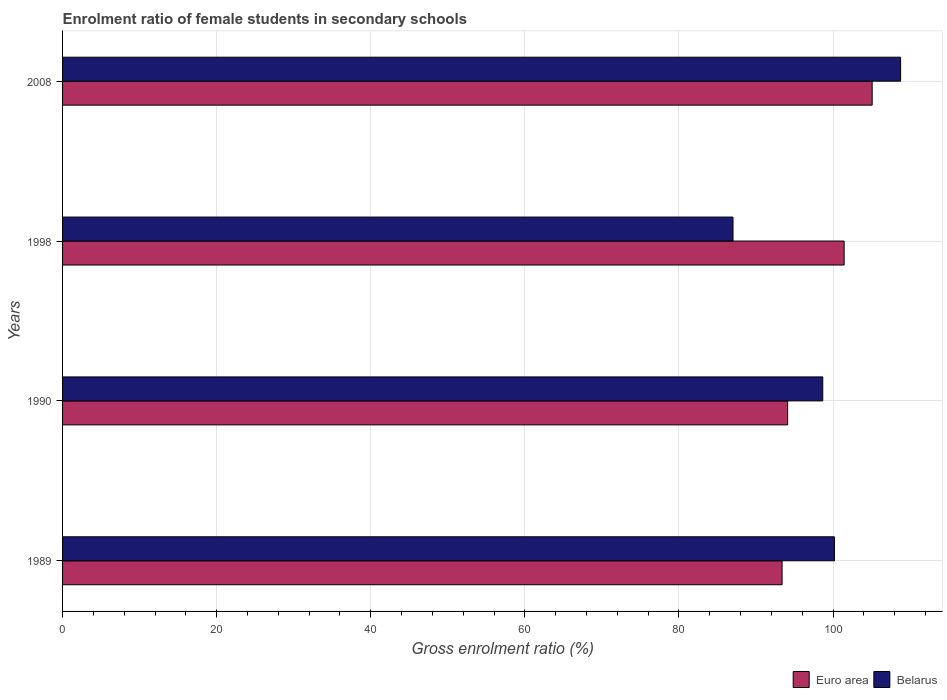How many different coloured bars are there?
Give a very brief answer. 2. How many groups of bars are there?
Your answer should be very brief. 4. Are the number of bars per tick equal to the number of legend labels?
Provide a succinct answer. Yes. Are the number of bars on each tick of the Y-axis equal?
Provide a succinct answer. Yes. How many bars are there on the 4th tick from the top?
Provide a short and direct response. 2. How many bars are there on the 2nd tick from the bottom?
Give a very brief answer. 2. What is the label of the 4th group of bars from the top?
Give a very brief answer. 1989. In how many cases, is the number of bars for a given year not equal to the number of legend labels?
Your answer should be very brief. 0. What is the enrolment ratio of female students in secondary schools in Belarus in 1998?
Offer a very short reply. 87.02. Across all years, what is the maximum enrolment ratio of female students in secondary schools in Belarus?
Provide a short and direct response. 108.77. Across all years, what is the minimum enrolment ratio of female students in secondary schools in Euro area?
Your response must be concise. 93.39. What is the total enrolment ratio of female students in secondary schools in Euro area in the graph?
Make the answer very short. 394.03. What is the difference between the enrolment ratio of female students in secondary schools in Euro area in 1990 and that in 1998?
Ensure brevity in your answer.  -7.33. What is the difference between the enrolment ratio of female students in secondary schools in Euro area in 1990 and the enrolment ratio of female students in secondary schools in Belarus in 2008?
Make the answer very short. -14.66. What is the average enrolment ratio of female students in secondary schools in Euro area per year?
Your answer should be compact. 98.51. In the year 1998, what is the difference between the enrolment ratio of female students in secondary schools in Belarus and enrolment ratio of female students in secondary schools in Euro area?
Offer a terse response. -14.43. What is the ratio of the enrolment ratio of female students in secondary schools in Belarus in 1990 to that in 1998?
Offer a very short reply. 1.13. Is the difference between the enrolment ratio of female students in secondary schools in Belarus in 1990 and 2008 greater than the difference between the enrolment ratio of female students in secondary schools in Euro area in 1990 and 2008?
Provide a succinct answer. Yes. What is the difference between the highest and the second highest enrolment ratio of female students in secondary schools in Belarus?
Offer a terse response. 8.59. What is the difference between the highest and the lowest enrolment ratio of female students in secondary schools in Euro area?
Offer a terse response. 11.69. In how many years, is the enrolment ratio of female students in secondary schools in Euro area greater than the average enrolment ratio of female students in secondary schools in Euro area taken over all years?
Offer a very short reply. 2. What does the 1st bar from the bottom in 2008 represents?
Ensure brevity in your answer.  Euro area. Does the graph contain grids?
Offer a terse response. Yes. Where does the legend appear in the graph?
Offer a very short reply. Bottom right. How many legend labels are there?
Offer a terse response. 2. What is the title of the graph?
Offer a terse response. Enrolment ratio of female students in secondary schools. What is the label or title of the X-axis?
Make the answer very short. Gross enrolment ratio (%). What is the label or title of the Y-axis?
Your answer should be very brief. Years. What is the Gross enrolment ratio (%) in Euro area in 1989?
Offer a terse response. 93.39. What is the Gross enrolment ratio (%) of Belarus in 1989?
Offer a very short reply. 100.19. What is the Gross enrolment ratio (%) of Euro area in 1990?
Make the answer very short. 94.11. What is the Gross enrolment ratio (%) of Belarus in 1990?
Make the answer very short. 98.67. What is the Gross enrolment ratio (%) of Euro area in 1998?
Provide a short and direct response. 101.45. What is the Gross enrolment ratio (%) of Belarus in 1998?
Your answer should be compact. 87.02. What is the Gross enrolment ratio (%) of Euro area in 2008?
Make the answer very short. 105.08. What is the Gross enrolment ratio (%) in Belarus in 2008?
Provide a short and direct response. 108.77. Across all years, what is the maximum Gross enrolment ratio (%) in Euro area?
Provide a succinct answer. 105.08. Across all years, what is the maximum Gross enrolment ratio (%) in Belarus?
Your response must be concise. 108.77. Across all years, what is the minimum Gross enrolment ratio (%) in Euro area?
Keep it short and to the point. 93.39. Across all years, what is the minimum Gross enrolment ratio (%) of Belarus?
Give a very brief answer. 87.02. What is the total Gross enrolment ratio (%) of Euro area in the graph?
Make the answer very short. 394.03. What is the total Gross enrolment ratio (%) in Belarus in the graph?
Keep it short and to the point. 394.65. What is the difference between the Gross enrolment ratio (%) of Euro area in 1989 and that in 1990?
Your answer should be very brief. -0.72. What is the difference between the Gross enrolment ratio (%) of Belarus in 1989 and that in 1990?
Offer a terse response. 1.51. What is the difference between the Gross enrolment ratio (%) in Euro area in 1989 and that in 1998?
Your answer should be very brief. -8.06. What is the difference between the Gross enrolment ratio (%) in Belarus in 1989 and that in 1998?
Provide a short and direct response. 13.17. What is the difference between the Gross enrolment ratio (%) of Euro area in 1989 and that in 2008?
Your answer should be very brief. -11.69. What is the difference between the Gross enrolment ratio (%) in Belarus in 1989 and that in 2008?
Offer a very short reply. -8.59. What is the difference between the Gross enrolment ratio (%) of Euro area in 1990 and that in 1998?
Your answer should be very brief. -7.33. What is the difference between the Gross enrolment ratio (%) of Belarus in 1990 and that in 1998?
Your answer should be very brief. 11.65. What is the difference between the Gross enrolment ratio (%) in Euro area in 1990 and that in 2008?
Your answer should be very brief. -10.97. What is the difference between the Gross enrolment ratio (%) in Belarus in 1990 and that in 2008?
Ensure brevity in your answer.  -10.1. What is the difference between the Gross enrolment ratio (%) in Euro area in 1998 and that in 2008?
Offer a very short reply. -3.64. What is the difference between the Gross enrolment ratio (%) in Belarus in 1998 and that in 2008?
Provide a succinct answer. -21.75. What is the difference between the Gross enrolment ratio (%) of Euro area in 1989 and the Gross enrolment ratio (%) of Belarus in 1990?
Keep it short and to the point. -5.28. What is the difference between the Gross enrolment ratio (%) in Euro area in 1989 and the Gross enrolment ratio (%) in Belarus in 1998?
Make the answer very short. 6.37. What is the difference between the Gross enrolment ratio (%) in Euro area in 1989 and the Gross enrolment ratio (%) in Belarus in 2008?
Give a very brief answer. -15.38. What is the difference between the Gross enrolment ratio (%) of Euro area in 1990 and the Gross enrolment ratio (%) of Belarus in 1998?
Your response must be concise. 7.09. What is the difference between the Gross enrolment ratio (%) of Euro area in 1990 and the Gross enrolment ratio (%) of Belarus in 2008?
Provide a short and direct response. -14.66. What is the difference between the Gross enrolment ratio (%) in Euro area in 1998 and the Gross enrolment ratio (%) in Belarus in 2008?
Your response must be concise. -7.33. What is the average Gross enrolment ratio (%) in Euro area per year?
Make the answer very short. 98.51. What is the average Gross enrolment ratio (%) of Belarus per year?
Offer a terse response. 98.66. In the year 1989, what is the difference between the Gross enrolment ratio (%) in Euro area and Gross enrolment ratio (%) in Belarus?
Your response must be concise. -6.8. In the year 1990, what is the difference between the Gross enrolment ratio (%) in Euro area and Gross enrolment ratio (%) in Belarus?
Provide a short and direct response. -4.56. In the year 1998, what is the difference between the Gross enrolment ratio (%) in Euro area and Gross enrolment ratio (%) in Belarus?
Provide a succinct answer. 14.43. In the year 2008, what is the difference between the Gross enrolment ratio (%) of Euro area and Gross enrolment ratio (%) of Belarus?
Provide a succinct answer. -3.69. What is the ratio of the Gross enrolment ratio (%) in Belarus in 1989 to that in 1990?
Offer a terse response. 1.02. What is the ratio of the Gross enrolment ratio (%) of Euro area in 1989 to that in 1998?
Your response must be concise. 0.92. What is the ratio of the Gross enrolment ratio (%) of Belarus in 1989 to that in 1998?
Your response must be concise. 1.15. What is the ratio of the Gross enrolment ratio (%) in Euro area in 1989 to that in 2008?
Ensure brevity in your answer.  0.89. What is the ratio of the Gross enrolment ratio (%) of Belarus in 1989 to that in 2008?
Provide a succinct answer. 0.92. What is the ratio of the Gross enrolment ratio (%) of Euro area in 1990 to that in 1998?
Provide a short and direct response. 0.93. What is the ratio of the Gross enrolment ratio (%) of Belarus in 1990 to that in 1998?
Make the answer very short. 1.13. What is the ratio of the Gross enrolment ratio (%) in Euro area in 1990 to that in 2008?
Ensure brevity in your answer.  0.9. What is the ratio of the Gross enrolment ratio (%) of Belarus in 1990 to that in 2008?
Keep it short and to the point. 0.91. What is the ratio of the Gross enrolment ratio (%) of Euro area in 1998 to that in 2008?
Provide a short and direct response. 0.97. What is the difference between the highest and the second highest Gross enrolment ratio (%) in Euro area?
Keep it short and to the point. 3.64. What is the difference between the highest and the second highest Gross enrolment ratio (%) in Belarus?
Give a very brief answer. 8.59. What is the difference between the highest and the lowest Gross enrolment ratio (%) of Euro area?
Your answer should be compact. 11.69. What is the difference between the highest and the lowest Gross enrolment ratio (%) of Belarus?
Offer a terse response. 21.75. 